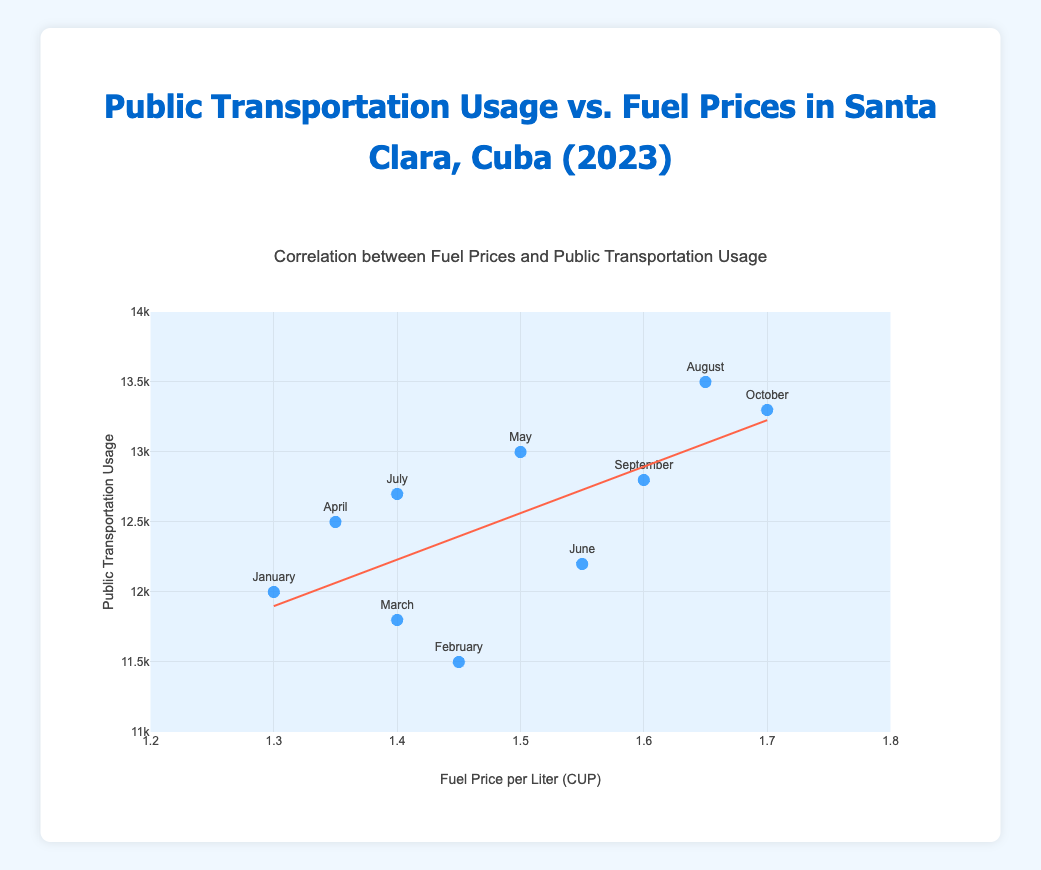What's the title of the chart? The title is located at the top of the chart. It reads: "Correlation between Fuel Prices and Public Transportation Usage".
Answer: Correlation between Fuel Prices and Public Transportation Usage What are the labels of the x-axis and y-axis? The x-axis is labeled "Fuel Price per Liter (CUP)", and the y-axis is labeled "Public Transportation Usage". This information is typically found near the respective axes.
Answer: Fuel Price per Liter (CUP) and Public Transportation Usage How many data points are there in the chart? By counting the number of markers (blue dots) on the scatter plot, we can see there are 10 data points. Each marker represents a month's data.
Answer: 10 What is the fuel price per liter in August 2023? By looking at the data point labeled "August" on the x-axis, we can see the fuel price for August 2023 is 1.65 CUP per liter.
Answer: 1.65 CUP per liter Which month has the highest public transportation usage, and what is the value? By looking at the y-values of the data points, the highest public transportation usage appears in August, with a value of 13,500.
Answer: August, 13,500 What is the trend shown by the trend line in the plot? The trend line shows a positive slope, indicating that as the fuel price per liter increases, the public transportation usage also tends to increase.
Answer: Positive correlation Which month has the lowest public transportation usage, and what is the fuel price in that month? By finding the lowest point on the y-axis, we see that February has the lowest public transportation usage at 11,500. The fuel price in February is 1.45 CUP per liter.
Answer: February, 1.45 CUP per liter Is there a clear correlation between fuel prices and public transportation usage? The trend line indicates a positive correlation, suggesting that higher fuel prices are associated with increased public transportation usage.
Answer: Yes What can we infer about the relationship between fuel prices and public transportation usage in Santa Clara, Cuba? Based on the upward sloping trend line, we infer that higher fuel prices likely motivate people to use public transportation more frequently.
Answer: Higher fuel prices lead to increased public transportation usage Compare the public transportation usage in January and October. What is the difference between these two months? January has a public transportation usage of 12,000, and October has 13,300. The difference is 13,300 - 12,000 = 1,300.
Answer: 1,300 